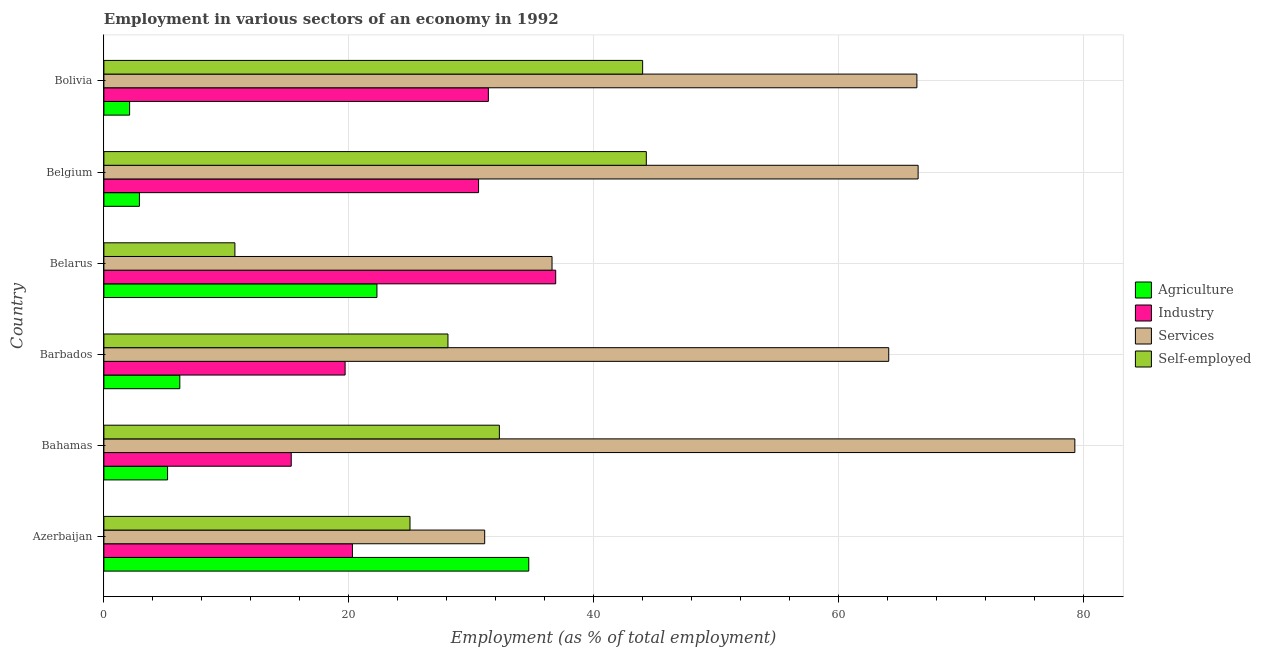How many different coloured bars are there?
Provide a short and direct response. 4. How many groups of bars are there?
Your answer should be very brief. 6. Are the number of bars on each tick of the Y-axis equal?
Offer a very short reply. Yes. How many bars are there on the 4th tick from the top?
Your answer should be very brief. 4. How many bars are there on the 5th tick from the bottom?
Offer a terse response. 4. What is the percentage of self employed workers in Barbados?
Make the answer very short. 28.1. Across all countries, what is the maximum percentage of workers in industry?
Offer a terse response. 36.9. Across all countries, what is the minimum percentage of workers in agriculture?
Offer a terse response. 2.1. In which country was the percentage of self employed workers minimum?
Your answer should be compact. Belarus. What is the total percentage of workers in agriculture in the graph?
Provide a succinct answer. 73.4. What is the difference between the percentage of self employed workers in Belgium and that in Bolivia?
Keep it short and to the point. 0.3. What is the difference between the percentage of self employed workers in Bolivia and the percentage of workers in services in Belgium?
Your answer should be very brief. -22.5. What is the average percentage of workers in services per country?
Provide a short and direct response. 57.33. What is the difference between the percentage of workers in services and percentage of workers in industry in Belgium?
Your answer should be compact. 35.9. In how many countries, is the percentage of workers in services greater than 32 %?
Your answer should be compact. 5. What is the ratio of the percentage of workers in agriculture in Azerbaijan to that in Belgium?
Your answer should be very brief. 11.97. Is the percentage of workers in services in Bahamas less than that in Bolivia?
Your response must be concise. No. What is the difference between the highest and the lowest percentage of workers in industry?
Offer a very short reply. 21.6. In how many countries, is the percentage of workers in industry greater than the average percentage of workers in industry taken over all countries?
Your answer should be compact. 3. Is it the case that in every country, the sum of the percentage of self employed workers and percentage of workers in industry is greater than the sum of percentage of workers in services and percentage of workers in agriculture?
Your response must be concise. No. What does the 1st bar from the top in Belarus represents?
Offer a very short reply. Self-employed. What does the 2nd bar from the bottom in Bahamas represents?
Your answer should be compact. Industry. Is it the case that in every country, the sum of the percentage of workers in agriculture and percentage of workers in industry is greater than the percentage of workers in services?
Your response must be concise. No. How many bars are there?
Offer a terse response. 24. Are all the bars in the graph horizontal?
Keep it short and to the point. Yes. What is the difference between two consecutive major ticks on the X-axis?
Your answer should be very brief. 20. Are the values on the major ticks of X-axis written in scientific E-notation?
Give a very brief answer. No. Does the graph contain any zero values?
Provide a short and direct response. No. How are the legend labels stacked?
Provide a short and direct response. Vertical. What is the title of the graph?
Offer a terse response. Employment in various sectors of an economy in 1992. Does "Offering training" appear as one of the legend labels in the graph?
Your answer should be compact. No. What is the label or title of the X-axis?
Make the answer very short. Employment (as % of total employment). What is the label or title of the Y-axis?
Offer a terse response. Country. What is the Employment (as % of total employment) in Agriculture in Azerbaijan?
Your answer should be very brief. 34.7. What is the Employment (as % of total employment) in Industry in Azerbaijan?
Offer a very short reply. 20.3. What is the Employment (as % of total employment) in Services in Azerbaijan?
Provide a short and direct response. 31.1. What is the Employment (as % of total employment) in Agriculture in Bahamas?
Your answer should be compact. 5.2. What is the Employment (as % of total employment) of Industry in Bahamas?
Make the answer very short. 15.3. What is the Employment (as % of total employment) of Services in Bahamas?
Offer a very short reply. 79.3. What is the Employment (as % of total employment) in Self-employed in Bahamas?
Give a very brief answer. 32.3. What is the Employment (as % of total employment) of Agriculture in Barbados?
Your response must be concise. 6.2. What is the Employment (as % of total employment) of Industry in Barbados?
Your answer should be very brief. 19.7. What is the Employment (as % of total employment) of Services in Barbados?
Make the answer very short. 64.1. What is the Employment (as % of total employment) in Self-employed in Barbados?
Your response must be concise. 28.1. What is the Employment (as % of total employment) of Agriculture in Belarus?
Provide a short and direct response. 22.3. What is the Employment (as % of total employment) in Industry in Belarus?
Your answer should be very brief. 36.9. What is the Employment (as % of total employment) in Services in Belarus?
Provide a short and direct response. 36.6. What is the Employment (as % of total employment) in Self-employed in Belarus?
Provide a short and direct response. 10.7. What is the Employment (as % of total employment) in Agriculture in Belgium?
Your answer should be compact. 2.9. What is the Employment (as % of total employment) in Industry in Belgium?
Offer a terse response. 30.6. What is the Employment (as % of total employment) of Services in Belgium?
Offer a very short reply. 66.5. What is the Employment (as % of total employment) in Self-employed in Belgium?
Ensure brevity in your answer.  44.3. What is the Employment (as % of total employment) of Agriculture in Bolivia?
Give a very brief answer. 2.1. What is the Employment (as % of total employment) in Industry in Bolivia?
Your response must be concise. 31.4. What is the Employment (as % of total employment) of Services in Bolivia?
Give a very brief answer. 66.4. Across all countries, what is the maximum Employment (as % of total employment) in Agriculture?
Keep it short and to the point. 34.7. Across all countries, what is the maximum Employment (as % of total employment) of Industry?
Your answer should be very brief. 36.9. Across all countries, what is the maximum Employment (as % of total employment) in Services?
Ensure brevity in your answer.  79.3. Across all countries, what is the maximum Employment (as % of total employment) in Self-employed?
Make the answer very short. 44.3. Across all countries, what is the minimum Employment (as % of total employment) of Agriculture?
Ensure brevity in your answer.  2.1. Across all countries, what is the minimum Employment (as % of total employment) in Industry?
Your answer should be very brief. 15.3. Across all countries, what is the minimum Employment (as % of total employment) of Services?
Your answer should be very brief. 31.1. Across all countries, what is the minimum Employment (as % of total employment) in Self-employed?
Ensure brevity in your answer.  10.7. What is the total Employment (as % of total employment) in Agriculture in the graph?
Your response must be concise. 73.4. What is the total Employment (as % of total employment) of Industry in the graph?
Your response must be concise. 154.2. What is the total Employment (as % of total employment) of Services in the graph?
Keep it short and to the point. 344. What is the total Employment (as % of total employment) in Self-employed in the graph?
Your response must be concise. 184.4. What is the difference between the Employment (as % of total employment) in Agriculture in Azerbaijan and that in Bahamas?
Make the answer very short. 29.5. What is the difference between the Employment (as % of total employment) in Industry in Azerbaijan and that in Bahamas?
Offer a very short reply. 5. What is the difference between the Employment (as % of total employment) in Services in Azerbaijan and that in Bahamas?
Your response must be concise. -48.2. What is the difference between the Employment (as % of total employment) in Self-employed in Azerbaijan and that in Bahamas?
Your answer should be very brief. -7.3. What is the difference between the Employment (as % of total employment) of Agriculture in Azerbaijan and that in Barbados?
Ensure brevity in your answer.  28.5. What is the difference between the Employment (as % of total employment) of Industry in Azerbaijan and that in Barbados?
Your answer should be compact. 0.6. What is the difference between the Employment (as % of total employment) of Services in Azerbaijan and that in Barbados?
Your answer should be very brief. -33. What is the difference between the Employment (as % of total employment) in Industry in Azerbaijan and that in Belarus?
Offer a terse response. -16.6. What is the difference between the Employment (as % of total employment) of Self-employed in Azerbaijan and that in Belarus?
Make the answer very short. 14.3. What is the difference between the Employment (as % of total employment) of Agriculture in Azerbaijan and that in Belgium?
Your answer should be compact. 31.8. What is the difference between the Employment (as % of total employment) of Industry in Azerbaijan and that in Belgium?
Make the answer very short. -10.3. What is the difference between the Employment (as % of total employment) in Services in Azerbaijan and that in Belgium?
Keep it short and to the point. -35.4. What is the difference between the Employment (as % of total employment) in Self-employed in Azerbaijan and that in Belgium?
Ensure brevity in your answer.  -19.3. What is the difference between the Employment (as % of total employment) of Agriculture in Azerbaijan and that in Bolivia?
Offer a very short reply. 32.6. What is the difference between the Employment (as % of total employment) of Services in Azerbaijan and that in Bolivia?
Your answer should be very brief. -35.3. What is the difference between the Employment (as % of total employment) of Self-employed in Azerbaijan and that in Bolivia?
Ensure brevity in your answer.  -19. What is the difference between the Employment (as % of total employment) in Services in Bahamas and that in Barbados?
Keep it short and to the point. 15.2. What is the difference between the Employment (as % of total employment) in Self-employed in Bahamas and that in Barbados?
Keep it short and to the point. 4.2. What is the difference between the Employment (as % of total employment) of Agriculture in Bahamas and that in Belarus?
Provide a succinct answer. -17.1. What is the difference between the Employment (as % of total employment) in Industry in Bahamas and that in Belarus?
Keep it short and to the point. -21.6. What is the difference between the Employment (as % of total employment) of Services in Bahamas and that in Belarus?
Provide a succinct answer. 42.7. What is the difference between the Employment (as % of total employment) in Self-employed in Bahamas and that in Belarus?
Provide a succinct answer. 21.6. What is the difference between the Employment (as % of total employment) of Agriculture in Bahamas and that in Belgium?
Make the answer very short. 2.3. What is the difference between the Employment (as % of total employment) of Industry in Bahamas and that in Belgium?
Your response must be concise. -15.3. What is the difference between the Employment (as % of total employment) in Self-employed in Bahamas and that in Belgium?
Keep it short and to the point. -12. What is the difference between the Employment (as % of total employment) of Agriculture in Bahamas and that in Bolivia?
Offer a very short reply. 3.1. What is the difference between the Employment (as % of total employment) in Industry in Bahamas and that in Bolivia?
Give a very brief answer. -16.1. What is the difference between the Employment (as % of total employment) in Services in Bahamas and that in Bolivia?
Provide a succinct answer. 12.9. What is the difference between the Employment (as % of total employment) in Agriculture in Barbados and that in Belarus?
Ensure brevity in your answer.  -16.1. What is the difference between the Employment (as % of total employment) in Industry in Barbados and that in Belarus?
Your answer should be compact. -17.2. What is the difference between the Employment (as % of total employment) of Agriculture in Barbados and that in Belgium?
Provide a short and direct response. 3.3. What is the difference between the Employment (as % of total employment) in Self-employed in Barbados and that in Belgium?
Provide a succinct answer. -16.2. What is the difference between the Employment (as % of total employment) of Agriculture in Barbados and that in Bolivia?
Your answer should be compact. 4.1. What is the difference between the Employment (as % of total employment) in Self-employed in Barbados and that in Bolivia?
Provide a short and direct response. -15.9. What is the difference between the Employment (as % of total employment) in Industry in Belarus and that in Belgium?
Provide a succinct answer. 6.3. What is the difference between the Employment (as % of total employment) in Services in Belarus and that in Belgium?
Your answer should be compact. -29.9. What is the difference between the Employment (as % of total employment) of Self-employed in Belarus and that in Belgium?
Give a very brief answer. -33.6. What is the difference between the Employment (as % of total employment) in Agriculture in Belarus and that in Bolivia?
Give a very brief answer. 20.2. What is the difference between the Employment (as % of total employment) of Industry in Belarus and that in Bolivia?
Offer a very short reply. 5.5. What is the difference between the Employment (as % of total employment) in Services in Belarus and that in Bolivia?
Provide a succinct answer. -29.8. What is the difference between the Employment (as % of total employment) of Self-employed in Belarus and that in Bolivia?
Provide a succinct answer. -33.3. What is the difference between the Employment (as % of total employment) in Agriculture in Azerbaijan and the Employment (as % of total employment) in Industry in Bahamas?
Keep it short and to the point. 19.4. What is the difference between the Employment (as % of total employment) in Agriculture in Azerbaijan and the Employment (as % of total employment) in Services in Bahamas?
Give a very brief answer. -44.6. What is the difference between the Employment (as % of total employment) of Industry in Azerbaijan and the Employment (as % of total employment) of Services in Bahamas?
Your answer should be compact. -59. What is the difference between the Employment (as % of total employment) in Services in Azerbaijan and the Employment (as % of total employment) in Self-employed in Bahamas?
Provide a short and direct response. -1.2. What is the difference between the Employment (as % of total employment) in Agriculture in Azerbaijan and the Employment (as % of total employment) in Industry in Barbados?
Your answer should be compact. 15. What is the difference between the Employment (as % of total employment) in Agriculture in Azerbaijan and the Employment (as % of total employment) in Services in Barbados?
Provide a succinct answer. -29.4. What is the difference between the Employment (as % of total employment) in Agriculture in Azerbaijan and the Employment (as % of total employment) in Self-employed in Barbados?
Provide a short and direct response. 6.6. What is the difference between the Employment (as % of total employment) of Industry in Azerbaijan and the Employment (as % of total employment) of Services in Barbados?
Ensure brevity in your answer.  -43.8. What is the difference between the Employment (as % of total employment) of Industry in Azerbaijan and the Employment (as % of total employment) of Services in Belarus?
Your answer should be very brief. -16.3. What is the difference between the Employment (as % of total employment) of Services in Azerbaijan and the Employment (as % of total employment) of Self-employed in Belarus?
Provide a short and direct response. 20.4. What is the difference between the Employment (as % of total employment) of Agriculture in Azerbaijan and the Employment (as % of total employment) of Services in Belgium?
Your answer should be compact. -31.8. What is the difference between the Employment (as % of total employment) in Agriculture in Azerbaijan and the Employment (as % of total employment) in Self-employed in Belgium?
Your response must be concise. -9.6. What is the difference between the Employment (as % of total employment) in Industry in Azerbaijan and the Employment (as % of total employment) in Services in Belgium?
Your response must be concise. -46.2. What is the difference between the Employment (as % of total employment) of Industry in Azerbaijan and the Employment (as % of total employment) of Self-employed in Belgium?
Offer a very short reply. -24. What is the difference between the Employment (as % of total employment) of Agriculture in Azerbaijan and the Employment (as % of total employment) of Industry in Bolivia?
Provide a succinct answer. 3.3. What is the difference between the Employment (as % of total employment) of Agriculture in Azerbaijan and the Employment (as % of total employment) of Services in Bolivia?
Your answer should be compact. -31.7. What is the difference between the Employment (as % of total employment) in Industry in Azerbaijan and the Employment (as % of total employment) in Services in Bolivia?
Your response must be concise. -46.1. What is the difference between the Employment (as % of total employment) of Industry in Azerbaijan and the Employment (as % of total employment) of Self-employed in Bolivia?
Provide a short and direct response. -23.7. What is the difference between the Employment (as % of total employment) in Agriculture in Bahamas and the Employment (as % of total employment) in Services in Barbados?
Provide a succinct answer. -58.9. What is the difference between the Employment (as % of total employment) in Agriculture in Bahamas and the Employment (as % of total employment) in Self-employed in Barbados?
Your answer should be compact. -22.9. What is the difference between the Employment (as % of total employment) of Industry in Bahamas and the Employment (as % of total employment) of Services in Barbados?
Offer a very short reply. -48.8. What is the difference between the Employment (as % of total employment) in Industry in Bahamas and the Employment (as % of total employment) in Self-employed in Barbados?
Offer a very short reply. -12.8. What is the difference between the Employment (as % of total employment) in Services in Bahamas and the Employment (as % of total employment) in Self-employed in Barbados?
Make the answer very short. 51.2. What is the difference between the Employment (as % of total employment) in Agriculture in Bahamas and the Employment (as % of total employment) in Industry in Belarus?
Offer a terse response. -31.7. What is the difference between the Employment (as % of total employment) of Agriculture in Bahamas and the Employment (as % of total employment) of Services in Belarus?
Offer a very short reply. -31.4. What is the difference between the Employment (as % of total employment) in Agriculture in Bahamas and the Employment (as % of total employment) in Self-employed in Belarus?
Provide a succinct answer. -5.5. What is the difference between the Employment (as % of total employment) in Industry in Bahamas and the Employment (as % of total employment) in Services in Belarus?
Your response must be concise. -21.3. What is the difference between the Employment (as % of total employment) of Services in Bahamas and the Employment (as % of total employment) of Self-employed in Belarus?
Provide a short and direct response. 68.6. What is the difference between the Employment (as % of total employment) in Agriculture in Bahamas and the Employment (as % of total employment) in Industry in Belgium?
Offer a terse response. -25.4. What is the difference between the Employment (as % of total employment) in Agriculture in Bahamas and the Employment (as % of total employment) in Services in Belgium?
Offer a terse response. -61.3. What is the difference between the Employment (as % of total employment) in Agriculture in Bahamas and the Employment (as % of total employment) in Self-employed in Belgium?
Ensure brevity in your answer.  -39.1. What is the difference between the Employment (as % of total employment) in Industry in Bahamas and the Employment (as % of total employment) in Services in Belgium?
Your response must be concise. -51.2. What is the difference between the Employment (as % of total employment) of Industry in Bahamas and the Employment (as % of total employment) of Self-employed in Belgium?
Give a very brief answer. -29. What is the difference between the Employment (as % of total employment) in Agriculture in Bahamas and the Employment (as % of total employment) in Industry in Bolivia?
Offer a very short reply. -26.2. What is the difference between the Employment (as % of total employment) in Agriculture in Bahamas and the Employment (as % of total employment) in Services in Bolivia?
Offer a terse response. -61.2. What is the difference between the Employment (as % of total employment) in Agriculture in Bahamas and the Employment (as % of total employment) in Self-employed in Bolivia?
Keep it short and to the point. -38.8. What is the difference between the Employment (as % of total employment) in Industry in Bahamas and the Employment (as % of total employment) in Services in Bolivia?
Ensure brevity in your answer.  -51.1. What is the difference between the Employment (as % of total employment) of Industry in Bahamas and the Employment (as % of total employment) of Self-employed in Bolivia?
Offer a very short reply. -28.7. What is the difference between the Employment (as % of total employment) in Services in Bahamas and the Employment (as % of total employment) in Self-employed in Bolivia?
Provide a succinct answer. 35.3. What is the difference between the Employment (as % of total employment) of Agriculture in Barbados and the Employment (as % of total employment) of Industry in Belarus?
Your answer should be compact. -30.7. What is the difference between the Employment (as % of total employment) of Agriculture in Barbados and the Employment (as % of total employment) of Services in Belarus?
Give a very brief answer. -30.4. What is the difference between the Employment (as % of total employment) of Agriculture in Barbados and the Employment (as % of total employment) of Self-employed in Belarus?
Give a very brief answer. -4.5. What is the difference between the Employment (as % of total employment) of Industry in Barbados and the Employment (as % of total employment) of Services in Belarus?
Give a very brief answer. -16.9. What is the difference between the Employment (as % of total employment) in Services in Barbados and the Employment (as % of total employment) in Self-employed in Belarus?
Offer a very short reply. 53.4. What is the difference between the Employment (as % of total employment) in Agriculture in Barbados and the Employment (as % of total employment) in Industry in Belgium?
Give a very brief answer. -24.4. What is the difference between the Employment (as % of total employment) of Agriculture in Barbados and the Employment (as % of total employment) of Services in Belgium?
Provide a short and direct response. -60.3. What is the difference between the Employment (as % of total employment) in Agriculture in Barbados and the Employment (as % of total employment) in Self-employed in Belgium?
Keep it short and to the point. -38.1. What is the difference between the Employment (as % of total employment) in Industry in Barbados and the Employment (as % of total employment) in Services in Belgium?
Your response must be concise. -46.8. What is the difference between the Employment (as % of total employment) of Industry in Barbados and the Employment (as % of total employment) of Self-employed in Belgium?
Offer a terse response. -24.6. What is the difference between the Employment (as % of total employment) of Services in Barbados and the Employment (as % of total employment) of Self-employed in Belgium?
Make the answer very short. 19.8. What is the difference between the Employment (as % of total employment) of Agriculture in Barbados and the Employment (as % of total employment) of Industry in Bolivia?
Your answer should be compact. -25.2. What is the difference between the Employment (as % of total employment) in Agriculture in Barbados and the Employment (as % of total employment) in Services in Bolivia?
Make the answer very short. -60.2. What is the difference between the Employment (as % of total employment) of Agriculture in Barbados and the Employment (as % of total employment) of Self-employed in Bolivia?
Your response must be concise. -37.8. What is the difference between the Employment (as % of total employment) in Industry in Barbados and the Employment (as % of total employment) in Services in Bolivia?
Offer a very short reply. -46.7. What is the difference between the Employment (as % of total employment) in Industry in Barbados and the Employment (as % of total employment) in Self-employed in Bolivia?
Your answer should be very brief. -24.3. What is the difference between the Employment (as % of total employment) in Services in Barbados and the Employment (as % of total employment) in Self-employed in Bolivia?
Offer a very short reply. 20.1. What is the difference between the Employment (as % of total employment) of Agriculture in Belarus and the Employment (as % of total employment) of Industry in Belgium?
Make the answer very short. -8.3. What is the difference between the Employment (as % of total employment) in Agriculture in Belarus and the Employment (as % of total employment) in Services in Belgium?
Ensure brevity in your answer.  -44.2. What is the difference between the Employment (as % of total employment) in Agriculture in Belarus and the Employment (as % of total employment) in Self-employed in Belgium?
Ensure brevity in your answer.  -22. What is the difference between the Employment (as % of total employment) in Industry in Belarus and the Employment (as % of total employment) in Services in Belgium?
Keep it short and to the point. -29.6. What is the difference between the Employment (as % of total employment) of Agriculture in Belarus and the Employment (as % of total employment) of Services in Bolivia?
Make the answer very short. -44.1. What is the difference between the Employment (as % of total employment) in Agriculture in Belarus and the Employment (as % of total employment) in Self-employed in Bolivia?
Offer a very short reply. -21.7. What is the difference between the Employment (as % of total employment) in Industry in Belarus and the Employment (as % of total employment) in Services in Bolivia?
Provide a succinct answer. -29.5. What is the difference between the Employment (as % of total employment) in Services in Belarus and the Employment (as % of total employment) in Self-employed in Bolivia?
Keep it short and to the point. -7.4. What is the difference between the Employment (as % of total employment) of Agriculture in Belgium and the Employment (as % of total employment) of Industry in Bolivia?
Make the answer very short. -28.5. What is the difference between the Employment (as % of total employment) in Agriculture in Belgium and the Employment (as % of total employment) in Services in Bolivia?
Keep it short and to the point. -63.5. What is the difference between the Employment (as % of total employment) of Agriculture in Belgium and the Employment (as % of total employment) of Self-employed in Bolivia?
Provide a short and direct response. -41.1. What is the difference between the Employment (as % of total employment) of Industry in Belgium and the Employment (as % of total employment) of Services in Bolivia?
Keep it short and to the point. -35.8. What is the difference between the Employment (as % of total employment) in Industry in Belgium and the Employment (as % of total employment) in Self-employed in Bolivia?
Offer a very short reply. -13.4. What is the average Employment (as % of total employment) in Agriculture per country?
Provide a short and direct response. 12.23. What is the average Employment (as % of total employment) of Industry per country?
Keep it short and to the point. 25.7. What is the average Employment (as % of total employment) in Services per country?
Provide a short and direct response. 57.33. What is the average Employment (as % of total employment) of Self-employed per country?
Provide a short and direct response. 30.73. What is the difference between the Employment (as % of total employment) of Agriculture and Employment (as % of total employment) of Services in Azerbaijan?
Provide a succinct answer. 3.6. What is the difference between the Employment (as % of total employment) in Industry and Employment (as % of total employment) in Services in Azerbaijan?
Offer a very short reply. -10.8. What is the difference between the Employment (as % of total employment) of Industry and Employment (as % of total employment) of Self-employed in Azerbaijan?
Ensure brevity in your answer.  -4.7. What is the difference between the Employment (as % of total employment) in Agriculture and Employment (as % of total employment) in Services in Bahamas?
Provide a succinct answer. -74.1. What is the difference between the Employment (as % of total employment) in Agriculture and Employment (as % of total employment) in Self-employed in Bahamas?
Your answer should be very brief. -27.1. What is the difference between the Employment (as % of total employment) of Industry and Employment (as % of total employment) of Services in Bahamas?
Your answer should be very brief. -64. What is the difference between the Employment (as % of total employment) in Services and Employment (as % of total employment) in Self-employed in Bahamas?
Keep it short and to the point. 47. What is the difference between the Employment (as % of total employment) of Agriculture and Employment (as % of total employment) of Industry in Barbados?
Your answer should be compact. -13.5. What is the difference between the Employment (as % of total employment) of Agriculture and Employment (as % of total employment) of Services in Barbados?
Provide a succinct answer. -57.9. What is the difference between the Employment (as % of total employment) in Agriculture and Employment (as % of total employment) in Self-employed in Barbados?
Your answer should be compact. -21.9. What is the difference between the Employment (as % of total employment) of Industry and Employment (as % of total employment) of Services in Barbados?
Your answer should be very brief. -44.4. What is the difference between the Employment (as % of total employment) in Industry and Employment (as % of total employment) in Self-employed in Barbados?
Offer a very short reply. -8.4. What is the difference between the Employment (as % of total employment) in Agriculture and Employment (as % of total employment) in Industry in Belarus?
Your response must be concise. -14.6. What is the difference between the Employment (as % of total employment) of Agriculture and Employment (as % of total employment) of Services in Belarus?
Your answer should be compact. -14.3. What is the difference between the Employment (as % of total employment) of Industry and Employment (as % of total employment) of Services in Belarus?
Ensure brevity in your answer.  0.3. What is the difference between the Employment (as % of total employment) of Industry and Employment (as % of total employment) of Self-employed in Belarus?
Give a very brief answer. 26.2. What is the difference between the Employment (as % of total employment) in Services and Employment (as % of total employment) in Self-employed in Belarus?
Your answer should be very brief. 25.9. What is the difference between the Employment (as % of total employment) in Agriculture and Employment (as % of total employment) in Industry in Belgium?
Ensure brevity in your answer.  -27.7. What is the difference between the Employment (as % of total employment) of Agriculture and Employment (as % of total employment) of Services in Belgium?
Keep it short and to the point. -63.6. What is the difference between the Employment (as % of total employment) in Agriculture and Employment (as % of total employment) in Self-employed in Belgium?
Provide a succinct answer. -41.4. What is the difference between the Employment (as % of total employment) in Industry and Employment (as % of total employment) in Services in Belgium?
Ensure brevity in your answer.  -35.9. What is the difference between the Employment (as % of total employment) of Industry and Employment (as % of total employment) of Self-employed in Belgium?
Offer a terse response. -13.7. What is the difference between the Employment (as % of total employment) in Services and Employment (as % of total employment) in Self-employed in Belgium?
Offer a very short reply. 22.2. What is the difference between the Employment (as % of total employment) of Agriculture and Employment (as % of total employment) of Industry in Bolivia?
Offer a terse response. -29.3. What is the difference between the Employment (as % of total employment) in Agriculture and Employment (as % of total employment) in Services in Bolivia?
Provide a short and direct response. -64.3. What is the difference between the Employment (as % of total employment) of Agriculture and Employment (as % of total employment) of Self-employed in Bolivia?
Give a very brief answer. -41.9. What is the difference between the Employment (as % of total employment) in Industry and Employment (as % of total employment) in Services in Bolivia?
Offer a terse response. -35. What is the difference between the Employment (as % of total employment) of Industry and Employment (as % of total employment) of Self-employed in Bolivia?
Ensure brevity in your answer.  -12.6. What is the difference between the Employment (as % of total employment) of Services and Employment (as % of total employment) of Self-employed in Bolivia?
Your response must be concise. 22.4. What is the ratio of the Employment (as % of total employment) in Agriculture in Azerbaijan to that in Bahamas?
Your response must be concise. 6.67. What is the ratio of the Employment (as % of total employment) of Industry in Azerbaijan to that in Bahamas?
Provide a short and direct response. 1.33. What is the ratio of the Employment (as % of total employment) in Services in Azerbaijan to that in Bahamas?
Your answer should be very brief. 0.39. What is the ratio of the Employment (as % of total employment) of Self-employed in Azerbaijan to that in Bahamas?
Your answer should be compact. 0.77. What is the ratio of the Employment (as % of total employment) of Agriculture in Azerbaijan to that in Barbados?
Keep it short and to the point. 5.6. What is the ratio of the Employment (as % of total employment) in Industry in Azerbaijan to that in Barbados?
Your answer should be very brief. 1.03. What is the ratio of the Employment (as % of total employment) in Services in Azerbaijan to that in Barbados?
Your response must be concise. 0.49. What is the ratio of the Employment (as % of total employment) of Self-employed in Azerbaijan to that in Barbados?
Make the answer very short. 0.89. What is the ratio of the Employment (as % of total employment) of Agriculture in Azerbaijan to that in Belarus?
Provide a short and direct response. 1.56. What is the ratio of the Employment (as % of total employment) in Industry in Azerbaijan to that in Belarus?
Your answer should be very brief. 0.55. What is the ratio of the Employment (as % of total employment) of Services in Azerbaijan to that in Belarus?
Give a very brief answer. 0.85. What is the ratio of the Employment (as % of total employment) of Self-employed in Azerbaijan to that in Belarus?
Your response must be concise. 2.34. What is the ratio of the Employment (as % of total employment) of Agriculture in Azerbaijan to that in Belgium?
Give a very brief answer. 11.97. What is the ratio of the Employment (as % of total employment) in Industry in Azerbaijan to that in Belgium?
Offer a very short reply. 0.66. What is the ratio of the Employment (as % of total employment) of Services in Azerbaijan to that in Belgium?
Provide a succinct answer. 0.47. What is the ratio of the Employment (as % of total employment) of Self-employed in Azerbaijan to that in Belgium?
Keep it short and to the point. 0.56. What is the ratio of the Employment (as % of total employment) of Agriculture in Azerbaijan to that in Bolivia?
Offer a very short reply. 16.52. What is the ratio of the Employment (as % of total employment) of Industry in Azerbaijan to that in Bolivia?
Provide a short and direct response. 0.65. What is the ratio of the Employment (as % of total employment) of Services in Azerbaijan to that in Bolivia?
Ensure brevity in your answer.  0.47. What is the ratio of the Employment (as % of total employment) in Self-employed in Azerbaijan to that in Bolivia?
Give a very brief answer. 0.57. What is the ratio of the Employment (as % of total employment) of Agriculture in Bahamas to that in Barbados?
Keep it short and to the point. 0.84. What is the ratio of the Employment (as % of total employment) of Industry in Bahamas to that in Barbados?
Your answer should be compact. 0.78. What is the ratio of the Employment (as % of total employment) of Services in Bahamas to that in Barbados?
Your answer should be very brief. 1.24. What is the ratio of the Employment (as % of total employment) of Self-employed in Bahamas to that in Barbados?
Your answer should be compact. 1.15. What is the ratio of the Employment (as % of total employment) of Agriculture in Bahamas to that in Belarus?
Provide a succinct answer. 0.23. What is the ratio of the Employment (as % of total employment) in Industry in Bahamas to that in Belarus?
Your response must be concise. 0.41. What is the ratio of the Employment (as % of total employment) in Services in Bahamas to that in Belarus?
Provide a short and direct response. 2.17. What is the ratio of the Employment (as % of total employment) in Self-employed in Bahamas to that in Belarus?
Your answer should be very brief. 3.02. What is the ratio of the Employment (as % of total employment) of Agriculture in Bahamas to that in Belgium?
Give a very brief answer. 1.79. What is the ratio of the Employment (as % of total employment) of Industry in Bahamas to that in Belgium?
Your answer should be compact. 0.5. What is the ratio of the Employment (as % of total employment) of Services in Bahamas to that in Belgium?
Provide a short and direct response. 1.19. What is the ratio of the Employment (as % of total employment) of Self-employed in Bahamas to that in Belgium?
Make the answer very short. 0.73. What is the ratio of the Employment (as % of total employment) in Agriculture in Bahamas to that in Bolivia?
Your answer should be compact. 2.48. What is the ratio of the Employment (as % of total employment) of Industry in Bahamas to that in Bolivia?
Your response must be concise. 0.49. What is the ratio of the Employment (as % of total employment) in Services in Bahamas to that in Bolivia?
Make the answer very short. 1.19. What is the ratio of the Employment (as % of total employment) of Self-employed in Bahamas to that in Bolivia?
Give a very brief answer. 0.73. What is the ratio of the Employment (as % of total employment) of Agriculture in Barbados to that in Belarus?
Provide a succinct answer. 0.28. What is the ratio of the Employment (as % of total employment) of Industry in Barbados to that in Belarus?
Give a very brief answer. 0.53. What is the ratio of the Employment (as % of total employment) in Services in Barbados to that in Belarus?
Provide a short and direct response. 1.75. What is the ratio of the Employment (as % of total employment) in Self-employed in Barbados to that in Belarus?
Make the answer very short. 2.63. What is the ratio of the Employment (as % of total employment) in Agriculture in Barbados to that in Belgium?
Give a very brief answer. 2.14. What is the ratio of the Employment (as % of total employment) in Industry in Barbados to that in Belgium?
Give a very brief answer. 0.64. What is the ratio of the Employment (as % of total employment) in Services in Barbados to that in Belgium?
Your response must be concise. 0.96. What is the ratio of the Employment (as % of total employment) in Self-employed in Barbados to that in Belgium?
Keep it short and to the point. 0.63. What is the ratio of the Employment (as % of total employment) in Agriculture in Barbados to that in Bolivia?
Your answer should be very brief. 2.95. What is the ratio of the Employment (as % of total employment) of Industry in Barbados to that in Bolivia?
Offer a very short reply. 0.63. What is the ratio of the Employment (as % of total employment) of Services in Barbados to that in Bolivia?
Provide a succinct answer. 0.97. What is the ratio of the Employment (as % of total employment) of Self-employed in Barbados to that in Bolivia?
Provide a short and direct response. 0.64. What is the ratio of the Employment (as % of total employment) in Agriculture in Belarus to that in Belgium?
Your response must be concise. 7.69. What is the ratio of the Employment (as % of total employment) of Industry in Belarus to that in Belgium?
Keep it short and to the point. 1.21. What is the ratio of the Employment (as % of total employment) of Services in Belarus to that in Belgium?
Offer a terse response. 0.55. What is the ratio of the Employment (as % of total employment) in Self-employed in Belarus to that in Belgium?
Offer a very short reply. 0.24. What is the ratio of the Employment (as % of total employment) in Agriculture in Belarus to that in Bolivia?
Provide a succinct answer. 10.62. What is the ratio of the Employment (as % of total employment) of Industry in Belarus to that in Bolivia?
Your answer should be very brief. 1.18. What is the ratio of the Employment (as % of total employment) of Services in Belarus to that in Bolivia?
Offer a very short reply. 0.55. What is the ratio of the Employment (as % of total employment) of Self-employed in Belarus to that in Bolivia?
Provide a succinct answer. 0.24. What is the ratio of the Employment (as % of total employment) of Agriculture in Belgium to that in Bolivia?
Your answer should be very brief. 1.38. What is the ratio of the Employment (as % of total employment) in Industry in Belgium to that in Bolivia?
Provide a succinct answer. 0.97. What is the ratio of the Employment (as % of total employment) in Services in Belgium to that in Bolivia?
Offer a terse response. 1. What is the ratio of the Employment (as % of total employment) in Self-employed in Belgium to that in Bolivia?
Ensure brevity in your answer.  1.01. What is the difference between the highest and the second highest Employment (as % of total employment) of Agriculture?
Provide a succinct answer. 12.4. What is the difference between the highest and the second highest Employment (as % of total employment) of Industry?
Give a very brief answer. 5.5. What is the difference between the highest and the second highest Employment (as % of total employment) in Services?
Provide a succinct answer. 12.8. What is the difference between the highest and the second highest Employment (as % of total employment) in Self-employed?
Your answer should be compact. 0.3. What is the difference between the highest and the lowest Employment (as % of total employment) of Agriculture?
Keep it short and to the point. 32.6. What is the difference between the highest and the lowest Employment (as % of total employment) in Industry?
Your answer should be compact. 21.6. What is the difference between the highest and the lowest Employment (as % of total employment) of Services?
Ensure brevity in your answer.  48.2. What is the difference between the highest and the lowest Employment (as % of total employment) in Self-employed?
Your answer should be very brief. 33.6. 